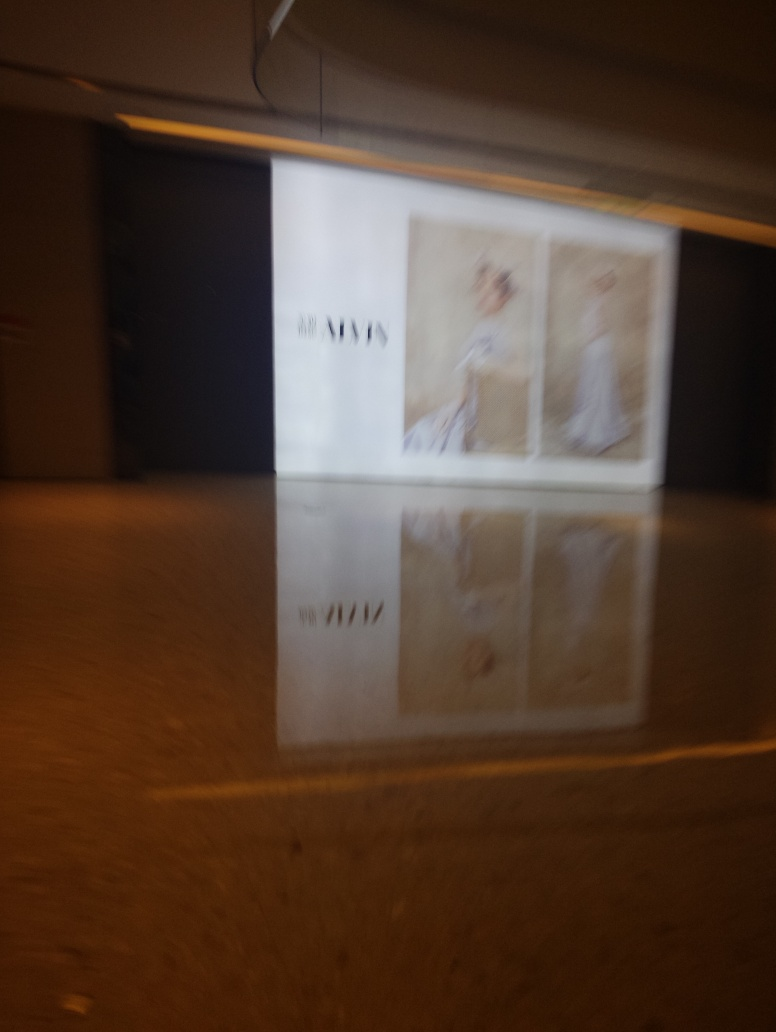What kind of setting does this image depict? The image seems to be taken in an indoor setting, potentially within a commercial or retail space. The presence of advertisement posters, along with ambient lighting and reflections on a polished floor, supports this interpretation. Does the image suggest movement or stillness? The blurriness of the photograph suggests movement. It is likely that the camera was in motion when the picture was taken, which implies a dynamic rather than a still environment at that moment. 